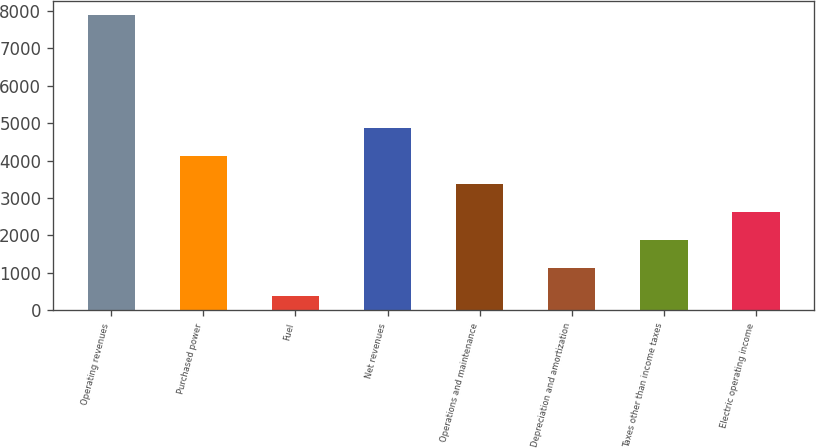Convert chart to OTSL. <chart><loc_0><loc_0><loc_500><loc_500><bar_chart><fcel>Operating revenues<fcel>Purchased power<fcel>Fuel<fcel>Net revenues<fcel>Operations and maintenance<fcel>Depreciation and amortization<fcel>Taxes other than income taxes<fcel>Electric operating income<nl><fcel>7878<fcel>4127<fcel>376<fcel>4877.2<fcel>3376.8<fcel>1126.2<fcel>1876.4<fcel>2626.6<nl></chart> 